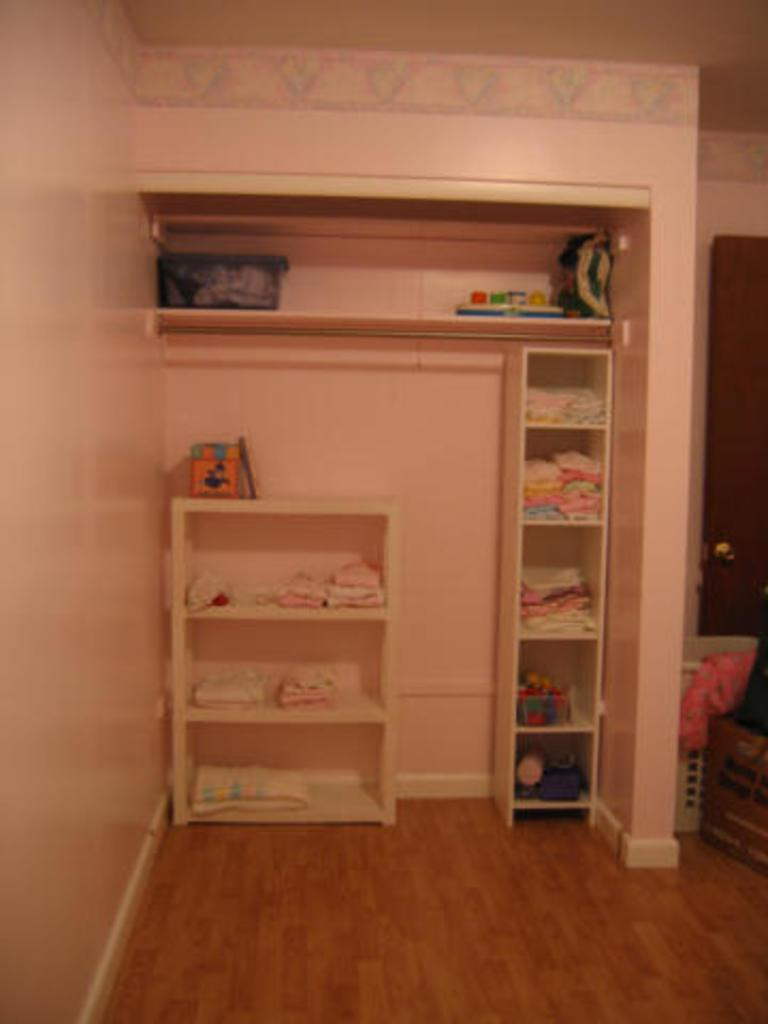What type of storage or display can be seen in the image? There are shelves in the image. What items are stored or displayed on the shelves? The shelves contain clothes. Is there any entrance or exit visible in the image? Yes, there is a door in the image. What type of soup is being served in the image? There is no soup present in the image; it features shelves with clothes and a door. 